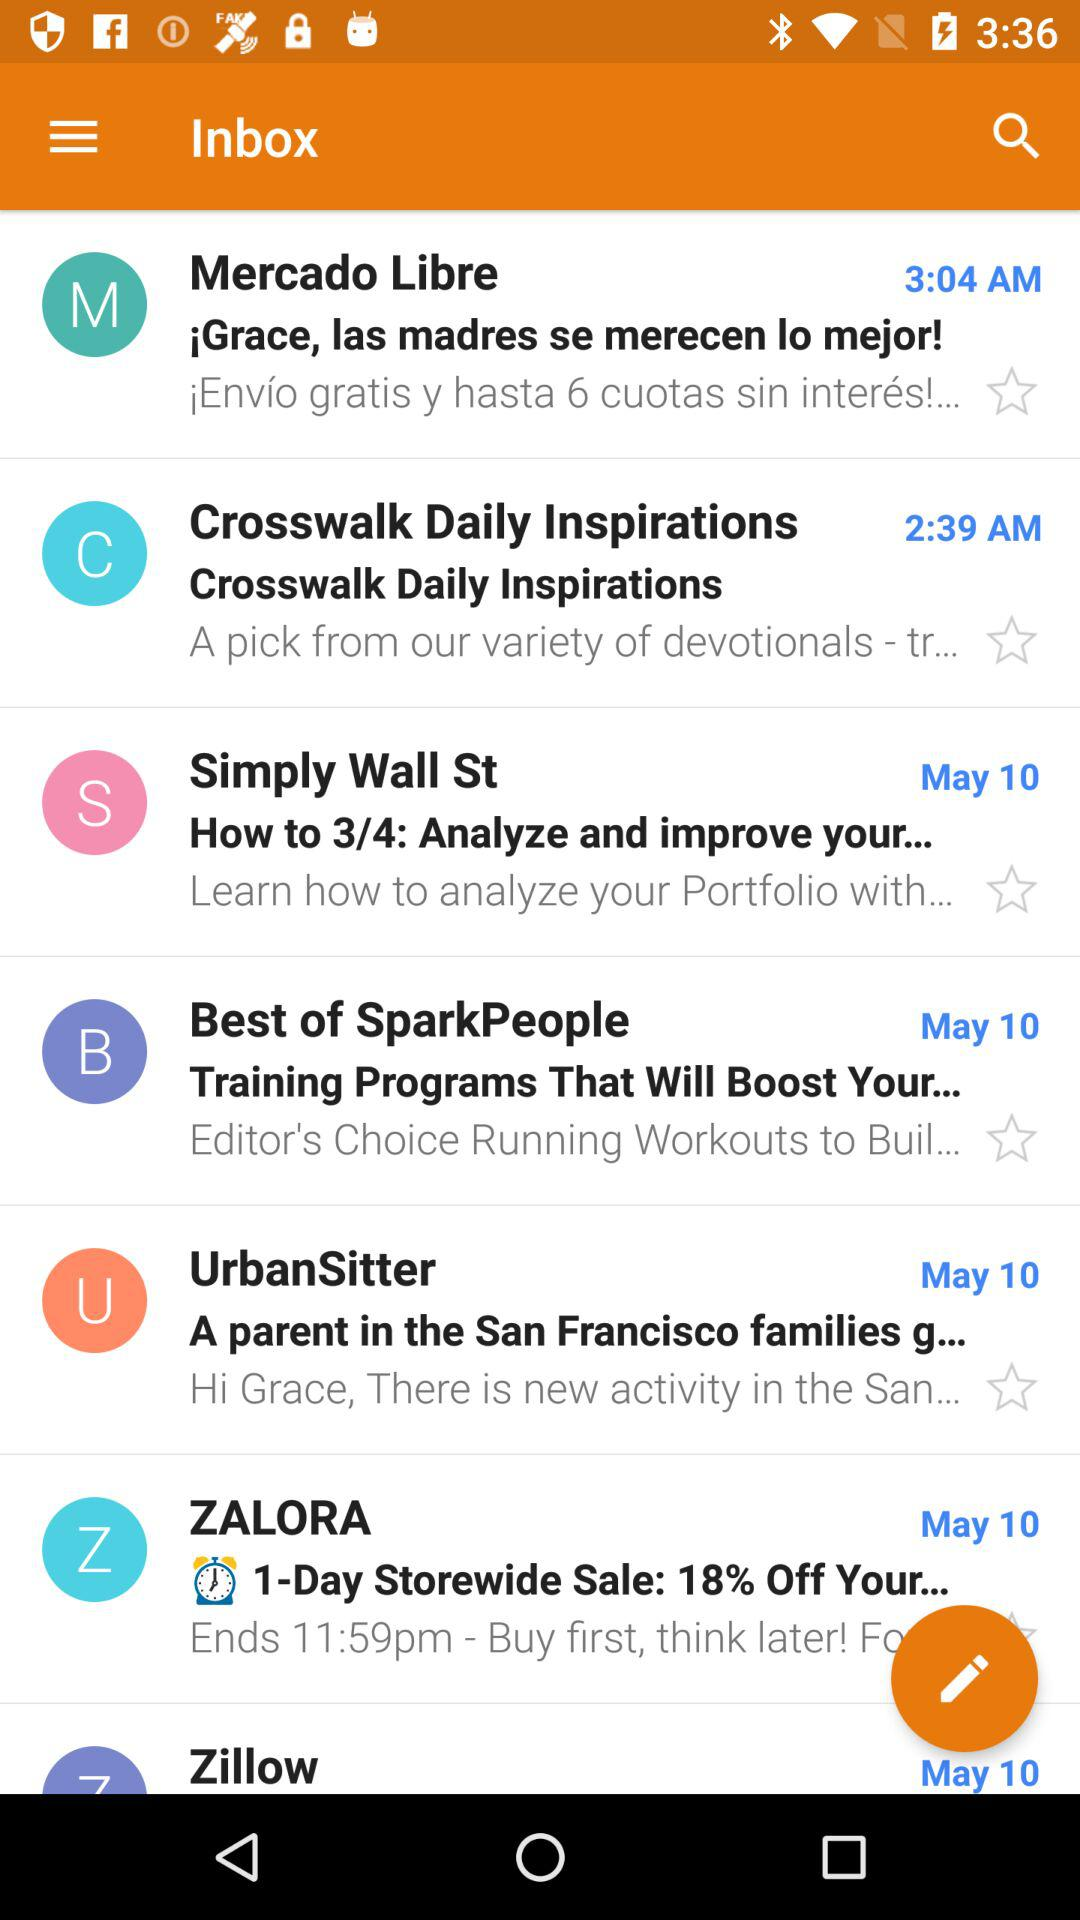Which mail did I receive at 3:04 AM? The mail is "¡Grace, las madres se merecen lo mejor!". 